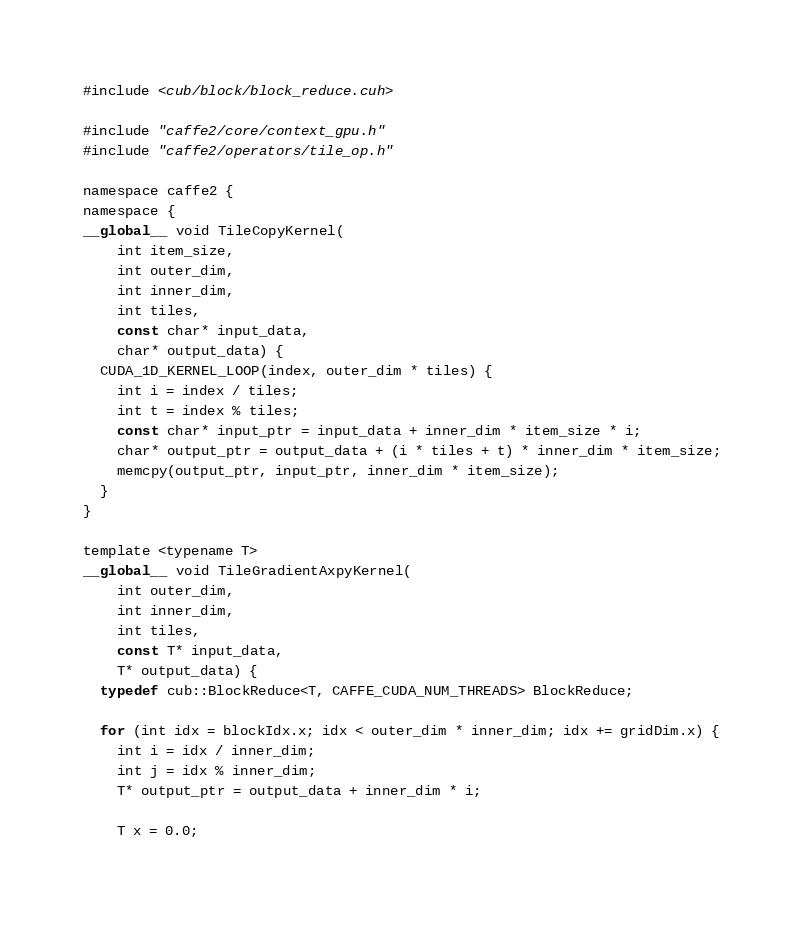<code> <loc_0><loc_0><loc_500><loc_500><_Cuda_>#include <cub/block/block_reduce.cuh>

#include "caffe2/core/context_gpu.h"
#include "caffe2/operators/tile_op.h"

namespace caffe2 {
namespace {
__global__ void TileCopyKernel(
    int item_size,
    int outer_dim,
    int inner_dim,
    int tiles,
    const char* input_data,
    char* output_data) {
  CUDA_1D_KERNEL_LOOP(index, outer_dim * tiles) {
    int i = index / tiles;
    int t = index % tiles;
    const char* input_ptr = input_data + inner_dim * item_size * i;
    char* output_ptr = output_data + (i * tiles + t) * inner_dim * item_size;
    memcpy(output_ptr, input_ptr, inner_dim * item_size);
  }
}

template <typename T>
__global__ void TileGradientAxpyKernel(
    int outer_dim,
    int inner_dim,
    int tiles,
    const T* input_data,
    T* output_data) {
  typedef cub::BlockReduce<T, CAFFE_CUDA_NUM_THREADS> BlockReduce;

  for (int idx = blockIdx.x; idx < outer_dim * inner_dim; idx += gridDim.x) {
    int i = idx / inner_dim;
    int j = idx % inner_dim;
    T* output_ptr = output_data + inner_dim * i;

    T x = 0.0;</code> 